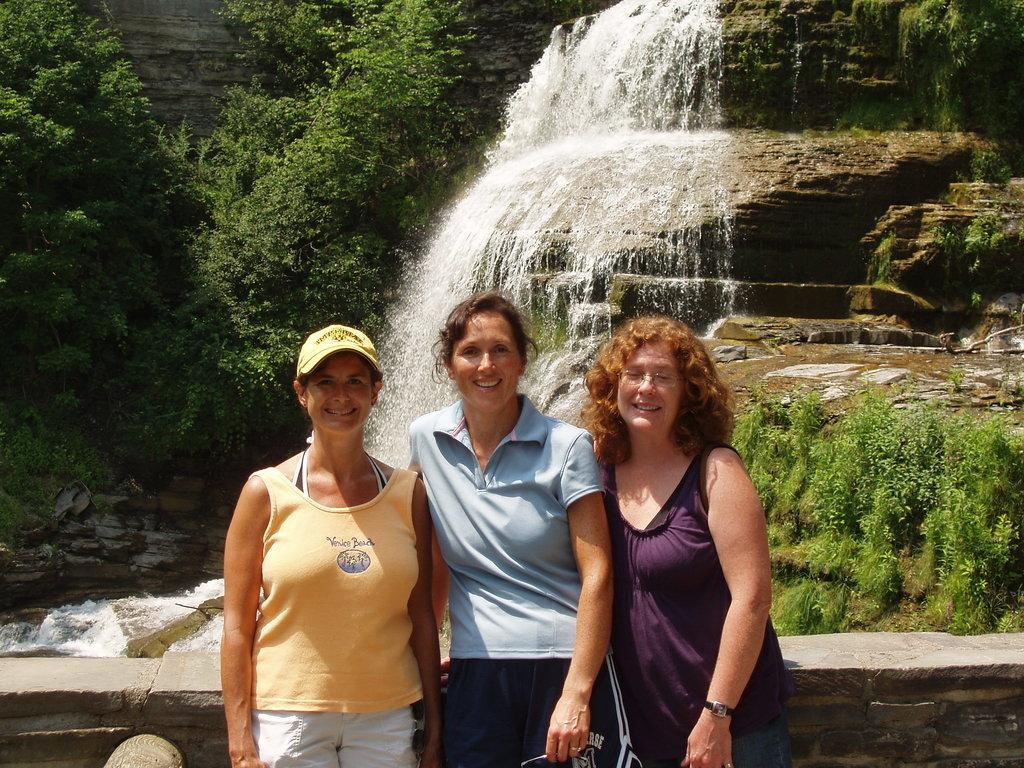How would you summarize this image in a sentence or two? In this picture we can see three women standing and smiling. There is a wall from left to right. We can see a waterfall and some trees in the background. 